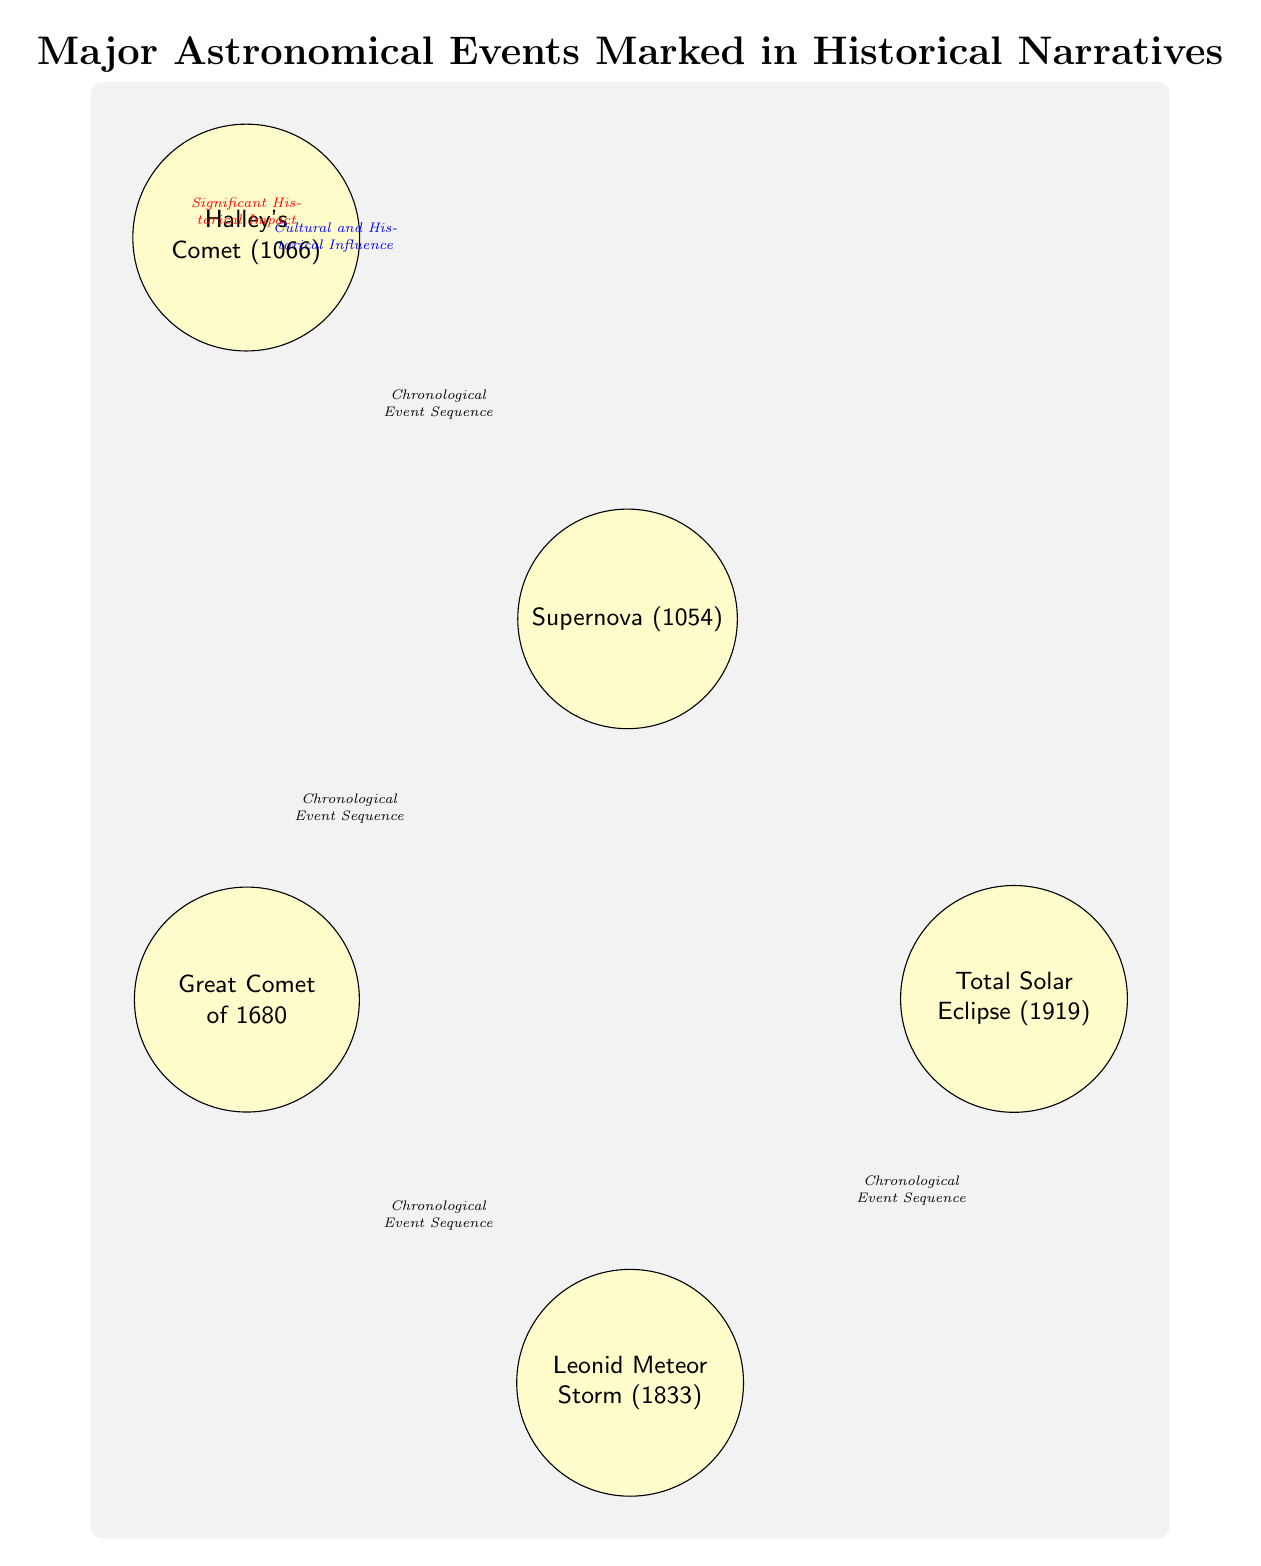What is the first major astronomical event noted in the diagram? The diagram indicates Halley's Comet as the first event, as it is placed at the topmost position, from where the sequence of events progresses downward.
Answer: Halley's Comet (1066) How many total major astronomical events are marked in the diagram? There are five events in the diagram: Halley's Comet, Supernova, Great Comet of 1680, Leonid Meteor Storm, and Total Solar Eclipse. Counting each node gives a total of five.
Answer: 5 What connects Halley's Comet and the Supernova? The diagram shows a direct connection indicated by an arrow, labeled "Chronological Event Sequence," which denotes their order in time.
Answer: Chronological Event Sequence Which two events have a dashed red connection? The dashed red line connects Halley's Comet and the Total Solar Eclipse, indicating a significant historical impact between these two events as per the diagram.
Answer: Halley's Comet (1066) and Total Solar Eclipse (1919) What is the relationship labeled between the Supernova and the Leonid Meteor Storm? The connection between these two events is denoted in the diagram as "Cultural and Historical Influence," showing how the Supernova may have influenced perspectives leading to the Leonid Meteor Storm.
Answer: Cultural and Historical Influence Which event is positioned immediately below the Supernova? The Great Comet of 1680 is located directly below the Supernova in the diagram, showcasing its sequential occurrence in relation to the Supernova.
Answer: Great Comet of 1680 What significant historical impact is indicated between Halley's Comet and the Total Solar Eclipse? The connection labeled with a dashed red line suggests their significant historical impact on narratives, establishing that both events are culturally relevant in history.
Answer: Significant Historical Impact How does the diagram illustrate the chronological sequence of events? The events are arranged in a downward sequence connected by arrows, clearly showing the order in which they occurred chronologically, facilitating understanding of historical timelines.
Answer: Chronological sequence What does the classification of nodes as ‘event’ in the diagram signify? Each node marked as 'event' represents a major astronomical occurrence in historical narratives, emphasizing their importance in documentary history.
Answer: Major astronomical occurrences 